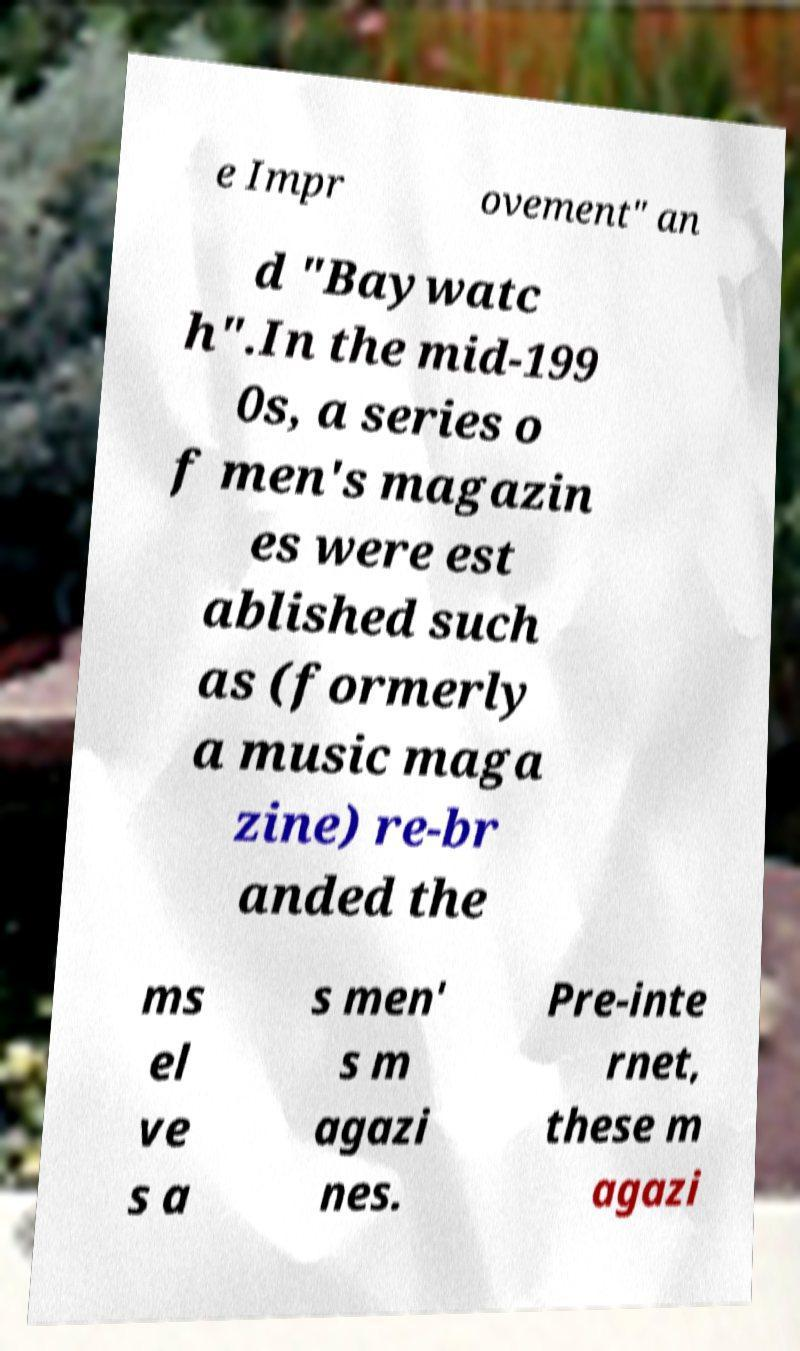I need the written content from this picture converted into text. Can you do that? e Impr ovement" an d "Baywatc h".In the mid-199 0s, a series o f men's magazin es were est ablished such as (formerly a music maga zine) re-br anded the ms el ve s a s men' s m agazi nes. Pre-inte rnet, these m agazi 